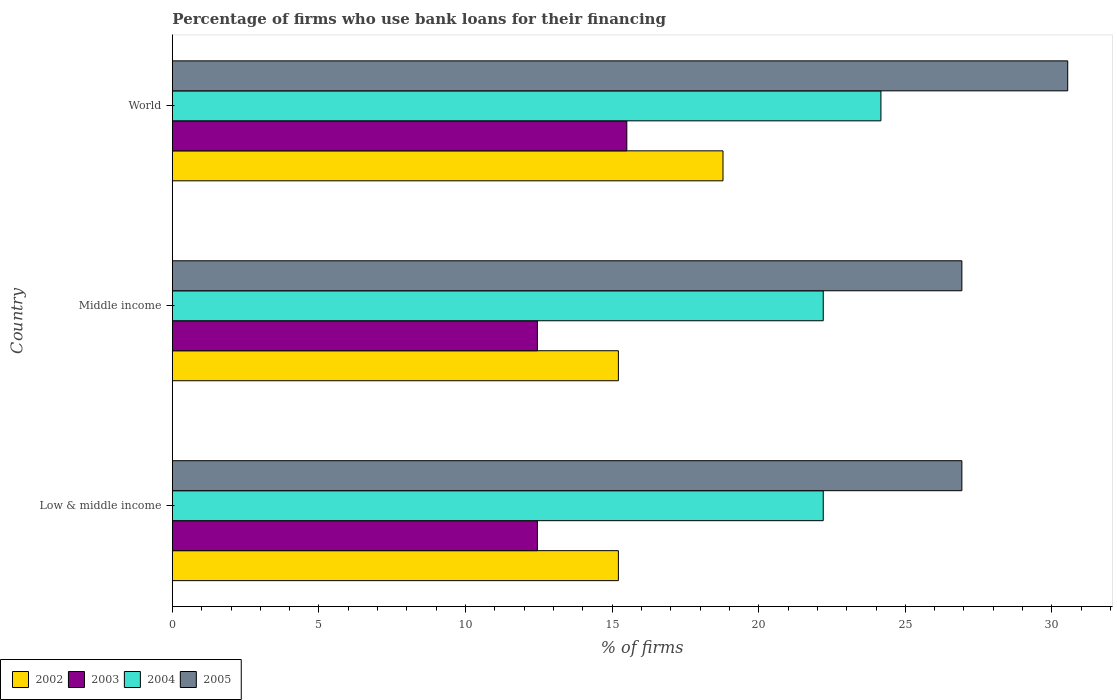Are the number of bars per tick equal to the number of legend labels?
Your response must be concise. Yes. Are the number of bars on each tick of the Y-axis equal?
Your answer should be very brief. Yes. How many bars are there on the 1st tick from the top?
Make the answer very short. 4. What is the label of the 3rd group of bars from the top?
Your answer should be compact. Low & middle income. What is the percentage of firms who use bank loans for their financing in 2004 in Middle income?
Keep it short and to the point. 22.2. Across all countries, what is the maximum percentage of firms who use bank loans for their financing in 2003?
Give a very brief answer. 15.5. Across all countries, what is the minimum percentage of firms who use bank loans for their financing in 2002?
Offer a terse response. 15.21. In which country was the percentage of firms who use bank loans for their financing in 2002 minimum?
Offer a terse response. Low & middle income. What is the total percentage of firms who use bank loans for their financing in 2005 in the graph?
Your response must be concise. 84.39. What is the difference between the percentage of firms who use bank loans for their financing in 2002 in Low & middle income and that in World?
Provide a succinct answer. -3.57. What is the difference between the percentage of firms who use bank loans for their financing in 2004 in Middle income and the percentage of firms who use bank loans for their financing in 2003 in Low & middle income?
Keep it short and to the point. 9.75. What is the average percentage of firms who use bank loans for their financing in 2002 per country?
Offer a very short reply. 16.4. What is the difference between the percentage of firms who use bank loans for their financing in 2005 and percentage of firms who use bank loans for their financing in 2004 in Middle income?
Provide a short and direct response. 4.73. What is the difference between the highest and the second highest percentage of firms who use bank loans for their financing in 2002?
Give a very brief answer. 3.57. What is the difference between the highest and the lowest percentage of firms who use bank loans for their financing in 2003?
Provide a short and direct response. 3.05. In how many countries, is the percentage of firms who use bank loans for their financing in 2005 greater than the average percentage of firms who use bank loans for their financing in 2005 taken over all countries?
Ensure brevity in your answer.  1. Is the sum of the percentage of firms who use bank loans for their financing in 2003 in Low & middle income and World greater than the maximum percentage of firms who use bank loans for their financing in 2004 across all countries?
Give a very brief answer. Yes. Is it the case that in every country, the sum of the percentage of firms who use bank loans for their financing in 2002 and percentage of firms who use bank loans for their financing in 2005 is greater than the sum of percentage of firms who use bank loans for their financing in 2003 and percentage of firms who use bank loans for their financing in 2004?
Make the answer very short. No. What does the 4th bar from the top in Middle income represents?
Your answer should be compact. 2002. What is the difference between two consecutive major ticks on the X-axis?
Make the answer very short. 5. Are the values on the major ticks of X-axis written in scientific E-notation?
Keep it short and to the point. No. Does the graph contain grids?
Provide a short and direct response. No. Where does the legend appear in the graph?
Your response must be concise. Bottom left. What is the title of the graph?
Keep it short and to the point. Percentage of firms who use bank loans for their financing. What is the label or title of the X-axis?
Provide a succinct answer. % of firms. What is the label or title of the Y-axis?
Offer a terse response. Country. What is the % of firms in 2002 in Low & middle income?
Make the answer very short. 15.21. What is the % of firms in 2003 in Low & middle income?
Keep it short and to the point. 12.45. What is the % of firms in 2004 in Low & middle income?
Offer a terse response. 22.2. What is the % of firms of 2005 in Low & middle income?
Keep it short and to the point. 26.93. What is the % of firms in 2002 in Middle income?
Offer a terse response. 15.21. What is the % of firms in 2003 in Middle income?
Provide a short and direct response. 12.45. What is the % of firms in 2004 in Middle income?
Your answer should be very brief. 22.2. What is the % of firms of 2005 in Middle income?
Make the answer very short. 26.93. What is the % of firms of 2002 in World?
Offer a terse response. 18.78. What is the % of firms in 2004 in World?
Offer a terse response. 24.17. What is the % of firms in 2005 in World?
Give a very brief answer. 30.54. Across all countries, what is the maximum % of firms in 2002?
Your answer should be very brief. 18.78. Across all countries, what is the maximum % of firms of 2003?
Provide a short and direct response. 15.5. Across all countries, what is the maximum % of firms in 2004?
Your answer should be compact. 24.17. Across all countries, what is the maximum % of firms in 2005?
Ensure brevity in your answer.  30.54. Across all countries, what is the minimum % of firms of 2002?
Your answer should be very brief. 15.21. Across all countries, what is the minimum % of firms of 2003?
Your answer should be very brief. 12.45. Across all countries, what is the minimum % of firms of 2004?
Provide a succinct answer. 22.2. Across all countries, what is the minimum % of firms of 2005?
Your answer should be compact. 26.93. What is the total % of firms in 2002 in the graph?
Provide a short and direct response. 49.21. What is the total % of firms in 2003 in the graph?
Provide a succinct answer. 40.4. What is the total % of firms in 2004 in the graph?
Offer a terse response. 68.57. What is the total % of firms of 2005 in the graph?
Your response must be concise. 84.39. What is the difference between the % of firms in 2004 in Low & middle income and that in Middle income?
Provide a short and direct response. 0. What is the difference between the % of firms of 2002 in Low & middle income and that in World?
Offer a very short reply. -3.57. What is the difference between the % of firms of 2003 in Low & middle income and that in World?
Your answer should be compact. -3.05. What is the difference between the % of firms of 2004 in Low & middle income and that in World?
Offer a terse response. -1.97. What is the difference between the % of firms in 2005 in Low & middle income and that in World?
Keep it short and to the point. -3.61. What is the difference between the % of firms of 2002 in Middle income and that in World?
Provide a succinct answer. -3.57. What is the difference between the % of firms of 2003 in Middle income and that in World?
Your answer should be very brief. -3.05. What is the difference between the % of firms in 2004 in Middle income and that in World?
Your answer should be compact. -1.97. What is the difference between the % of firms of 2005 in Middle income and that in World?
Keep it short and to the point. -3.61. What is the difference between the % of firms of 2002 in Low & middle income and the % of firms of 2003 in Middle income?
Make the answer very short. 2.76. What is the difference between the % of firms of 2002 in Low & middle income and the % of firms of 2004 in Middle income?
Offer a very short reply. -6.99. What is the difference between the % of firms in 2002 in Low & middle income and the % of firms in 2005 in Middle income?
Your response must be concise. -11.72. What is the difference between the % of firms in 2003 in Low & middle income and the % of firms in 2004 in Middle income?
Make the answer very short. -9.75. What is the difference between the % of firms of 2003 in Low & middle income and the % of firms of 2005 in Middle income?
Keep it short and to the point. -14.48. What is the difference between the % of firms of 2004 in Low & middle income and the % of firms of 2005 in Middle income?
Your answer should be very brief. -4.73. What is the difference between the % of firms in 2002 in Low & middle income and the % of firms in 2003 in World?
Provide a succinct answer. -0.29. What is the difference between the % of firms of 2002 in Low & middle income and the % of firms of 2004 in World?
Offer a very short reply. -8.95. What is the difference between the % of firms in 2002 in Low & middle income and the % of firms in 2005 in World?
Your answer should be compact. -15.33. What is the difference between the % of firms in 2003 in Low & middle income and the % of firms in 2004 in World?
Keep it short and to the point. -11.72. What is the difference between the % of firms in 2003 in Low & middle income and the % of firms in 2005 in World?
Your answer should be very brief. -18.09. What is the difference between the % of firms in 2004 in Low & middle income and the % of firms in 2005 in World?
Provide a short and direct response. -8.34. What is the difference between the % of firms of 2002 in Middle income and the % of firms of 2003 in World?
Provide a succinct answer. -0.29. What is the difference between the % of firms in 2002 in Middle income and the % of firms in 2004 in World?
Make the answer very short. -8.95. What is the difference between the % of firms in 2002 in Middle income and the % of firms in 2005 in World?
Offer a very short reply. -15.33. What is the difference between the % of firms of 2003 in Middle income and the % of firms of 2004 in World?
Offer a very short reply. -11.72. What is the difference between the % of firms of 2003 in Middle income and the % of firms of 2005 in World?
Your answer should be compact. -18.09. What is the difference between the % of firms of 2004 in Middle income and the % of firms of 2005 in World?
Offer a terse response. -8.34. What is the average % of firms in 2002 per country?
Your answer should be very brief. 16.4. What is the average % of firms in 2003 per country?
Ensure brevity in your answer.  13.47. What is the average % of firms in 2004 per country?
Make the answer very short. 22.86. What is the average % of firms in 2005 per country?
Your answer should be very brief. 28.13. What is the difference between the % of firms of 2002 and % of firms of 2003 in Low & middle income?
Make the answer very short. 2.76. What is the difference between the % of firms of 2002 and % of firms of 2004 in Low & middle income?
Make the answer very short. -6.99. What is the difference between the % of firms of 2002 and % of firms of 2005 in Low & middle income?
Keep it short and to the point. -11.72. What is the difference between the % of firms of 2003 and % of firms of 2004 in Low & middle income?
Give a very brief answer. -9.75. What is the difference between the % of firms in 2003 and % of firms in 2005 in Low & middle income?
Your response must be concise. -14.48. What is the difference between the % of firms of 2004 and % of firms of 2005 in Low & middle income?
Give a very brief answer. -4.73. What is the difference between the % of firms in 2002 and % of firms in 2003 in Middle income?
Ensure brevity in your answer.  2.76. What is the difference between the % of firms of 2002 and % of firms of 2004 in Middle income?
Provide a succinct answer. -6.99. What is the difference between the % of firms in 2002 and % of firms in 2005 in Middle income?
Keep it short and to the point. -11.72. What is the difference between the % of firms in 2003 and % of firms in 2004 in Middle income?
Offer a very short reply. -9.75. What is the difference between the % of firms of 2003 and % of firms of 2005 in Middle income?
Offer a very short reply. -14.48. What is the difference between the % of firms of 2004 and % of firms of 2005 in Middle income?
Provide a succinct answer. -4.73. What is the difference between the % of firms in 2002 and % of firms in 2003 in World?
Give a very brief answer. 3.28. What is the difference between the % of firms in 2002 and % of firms in 2004 in World?
Make the answer very short. -5.39. What is the difference between the % of firms in 2002 and % of firms in 2005 in World?
Ensure brevity in your answer.  -11.76. What is the difference between the % of firms in 2003 and % of firms in 2004 in World?
Keep it short and to the point. -8.67. What is the difference between the % of firms in 2003 and % of firms in 2005 in World?
Provide a succinct answer. -15.04. What is the difference between the % of firms of 2004 and % of firms of 2005 in World?
Your response must be concise. -6.37. What is the ratio of the % of firms of 2002 in Low & middle income to that in Middle income?
Provide a short and direct response. 1. What is the ratio of the % of firms in 2003 in Low & middle income to that in Middle income?
Offer a very short reply. 1. What is the ratio of the % of firms of 2004 in Low & middle income to that in Middle income?
Keep it short and to the point. 1. What is the ratio of the % of firms in 2005 in Low & middle income to that in Middle income?
Your answer should be very brief. 1. What is the ratio of the % of firms in 2002 in Low & middle income to that in World?
Provide a short and direct response. 0.81. What is the ratio of the % of firms in 2003 in Low & middle income to that in World?
Give a very brief answer. 0.8. What is the ratio of the % of firms in 2004 in Low & middle income to that in World?
Provide a succinct answer. 0.92. What is the ratio of the % of firms of 2005 in Low & middle income to that in World?
Provide a succinct answer. 0.88. What is the ratio of the % of firms of 2002 in Middle income to that in World?
Offer a very short reply. 0.81. What is the ratio of the % of firms of 2003 in Middle income to that in World?
Your response must be concise. 0.8. What is the ratio of the % of firms of 2004 in Middle income to that in World?
Ensure brevity in your answer.  0.92. What is the ratio of the % of firms of 2005 in Middle income to that in World?
Keep it short and to the point. 0.88. What is the difference between the highest and the second highest % of firms in 2002?
Ensure brevity in your answer.  3.57. What is the difference between the highest and the second highest % of firms of 2003?
Provide a short and direct response. 3.05. What is the difference between the highest and the second highest % of firms of 2004?
Give a very brief answer. 1.97. What is the difference between the highest and the second highest % of firms of 2005?
Provide a succinct answer. 3.61. What is the difference between the highest and the lowest % of firms in 2002?
Offer a very short reply. 3.57. What is the difference between the highest and the lowest % of firms of 2003?
Offer a terse response. 3.05. What is the difference between the highest and the lowest % of firms in 2004?
Offer a very short reply. 1.97. What is the difference between the highest and the lowest % of firms of 2005?
Provide a short and direct response. 3.61. 